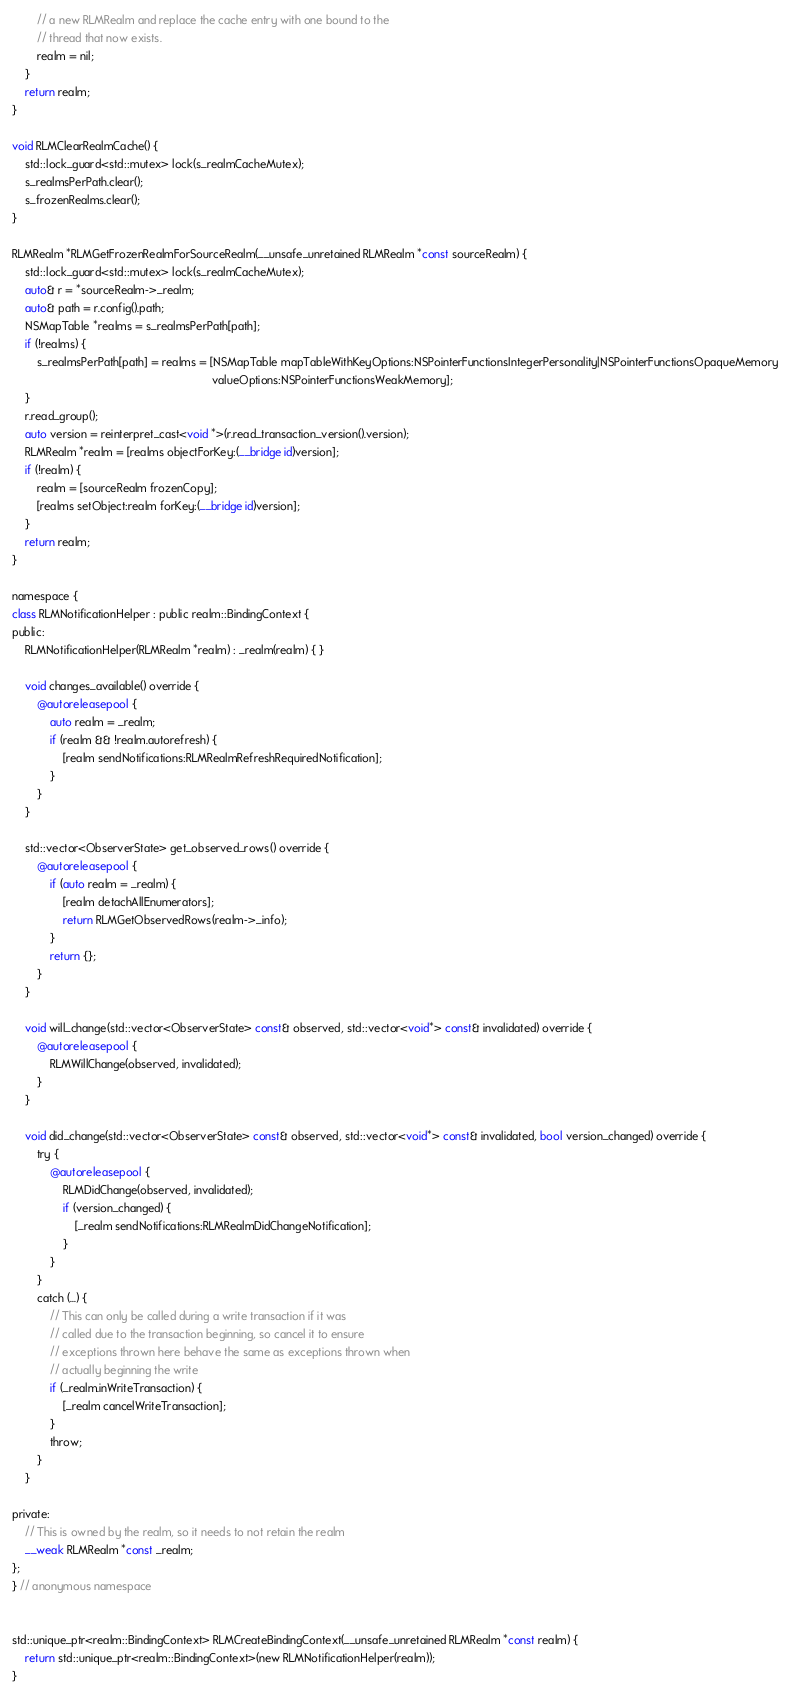Convert code to text. <code><loc_0><loc_0><loc_500><loc_500><_ObjectiveC_>        // a new RLMRealm and replace the cache entry with one bound to the
        // thread that now exists.
        realm = nil;
    }
    return realm;
}

void RLMClearRealmCache() {
    std::lock_guard<std::mutex> lock(s_realmCacheMutex);
    s_realmsPerPath.clear();
    s_frozenRealms.clear();
}

RLMRealm *RLMGetFrozenRealmForSourceRealm(__unsafe_unretained RLMRealm *const sourceRealm) {
    std::lock_guard<std::mutex> lock(s_realmCacheMutex);
    auto& r = *sourceRealm->_realm;
    auto& path = r.config().path;
    NSMapTable *realms = s_realmsPerPath[path];
    if (!realms) {
        s_realmsPerPath[path] = realms = [NSMapTable mapTableWithKeyOptions:NSPointerFunctionsIntegerPersonality|NSPointerFunctionsOpaqueMemory
                                                               valueOptions:NSPointerFunctionsWeakMemory];
    }
    r.read_group();
    auto version = reinterpret_cast<void *>(r.read_transaction_version().version);
    RLMRealm *realm = [realms objectForKey:(__bridge id)version];
    if (!realm) {
        realm = [sourceRealm frozenCopy];
        [realms setObject:realm forKey:(__bridge id)version];
    }
    return realm;
}

namespace {
class RLMNotificationHelper : public realm::BindingContext {
public:
    RLMNotificationHelper(RLMRealm *realm) : _realm(realm) { }

    void changes_available() override {
        @autoreleasepool {
            auto realm = _realm;
            if (realm && !realm.autorefresh) {
                [realm sendNotifications:RLMRealmRefreshRequiredNotification];
            }
        }
    }

    std::vector<ObserverState> get_observed_rows() override {
        @autoreleasepool {
            if (auto realm = _realm) {
                [realm detachAllEnumerators];
                return RLMGetObservedRows(realm->_info);
            }
            return {};
        }
    }

    void will_change(std::vector<ObserverState> const& observed, std::vector<void*> const& invalidated) override {
        @autoreleasepool {
            RLMWillChange(observed, invalidated);
        }
    }

    void did_change(std::vector<ObserverState> const& observed, std::vector<void*> const& invalidated, bool version_changed) override {
        try {
            @autoreleasepool {
                RLMDidChange(observed, invalidated);
                if (version_changed) {
                    [_realm sendNotifications:RLMRealmDidChangeNotification];
                }
            }
        }
        catch (...) {
            // This can only be called during a write transaction if it was
            // called due to the transaction beginning, so cancel it to ensure
            // exceptions thrown here behave the same as exceptions thrown when
            // actually beginning the write
            if (_realm.inWriteTransaction) {
                [_realm cancelWriteTransaction];
            }
            throw;
        }
    }

private:
    // This is owned by the realm, so it needs to not retain the realm
    __weak RLMRealm *const _realm;
};
} // anonymous namespace


std::unique_ptr<realm::BindingContext> RLMCreateBindingContext(__unsafe_unretained RLMRealm *const realm) {
    return std::unique_ptr<realm::BindingContext>(new RLMNotificationHelper(realm));
}
</code> 